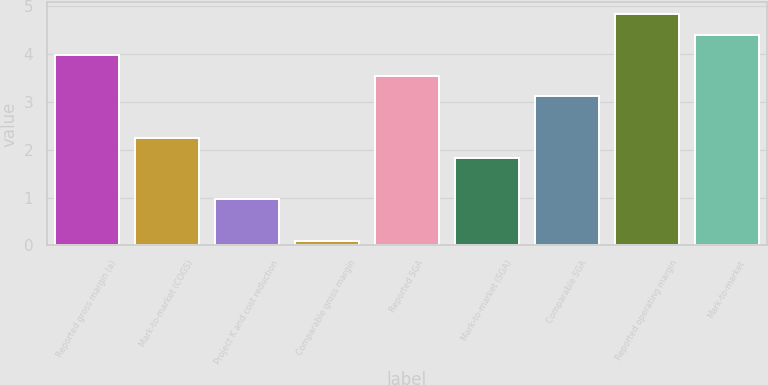<chart> <loc_0><loc_0><loc_500><loc_500><bar_chart><fcel>Reported gross margin (a)<fcel>Mark-to-market (COGS)<fcel>Project K and cost reduction<fcel>Comparable gross margin<fcel>Reported SGA<fcel>Mark-to-market (SGA)<fcel>Comparable SGA<fcel>Reported operating margin<fcel>Mark-to-market<nl><fcel>3.97<fcel>2.25<fcel>0.96<fcel>0.1<fcel>3.54<fcel>1.82<fcel>3.11<fcel>4.83<fcel>4.4<nl></chart> 